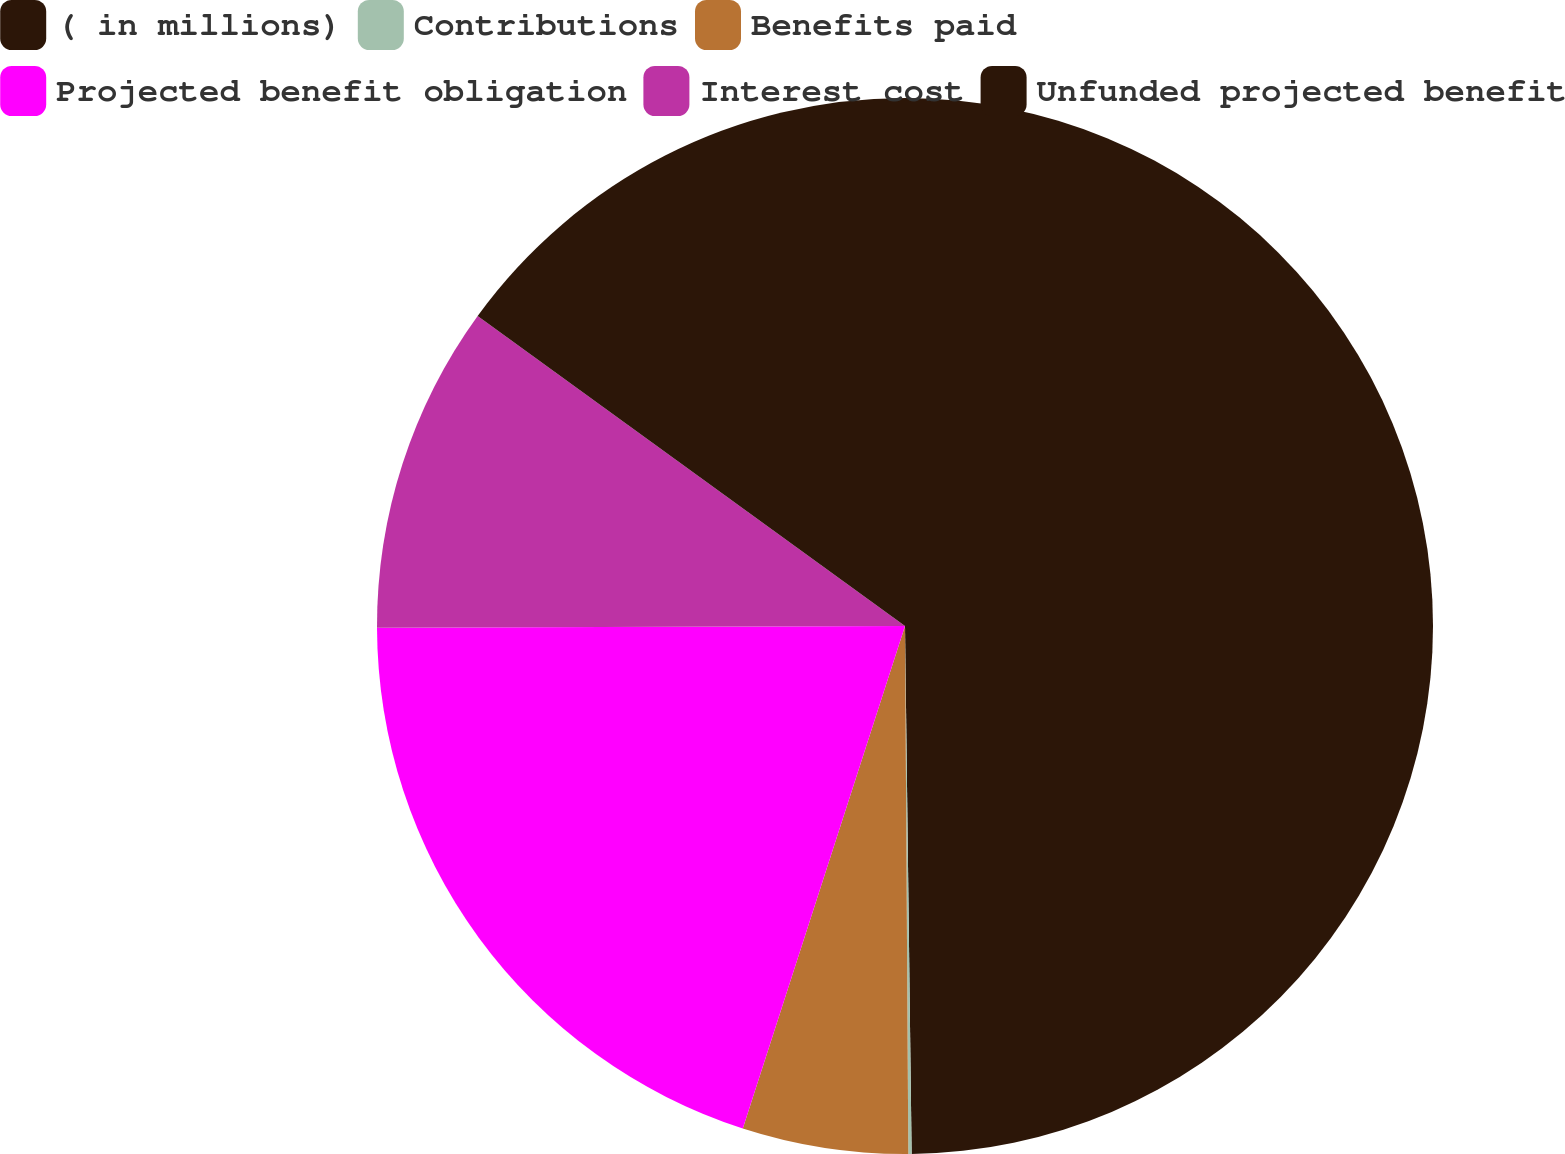<chart> <loc_0><loc_0><loc_500><loc_500><pie_chart><fcel>( in millions)<fcel>Contributions<fcel>Benefits paid<fcel>Projected benefit obligation<fcel>Interest cost<fcel>Unfunded projected benefit<nl><fcel>49.8%<fcel>0.1%<fcel>5.07%<fcel>19.98%<fcel>10.04%<fcel>15.01%<nl></chart> 